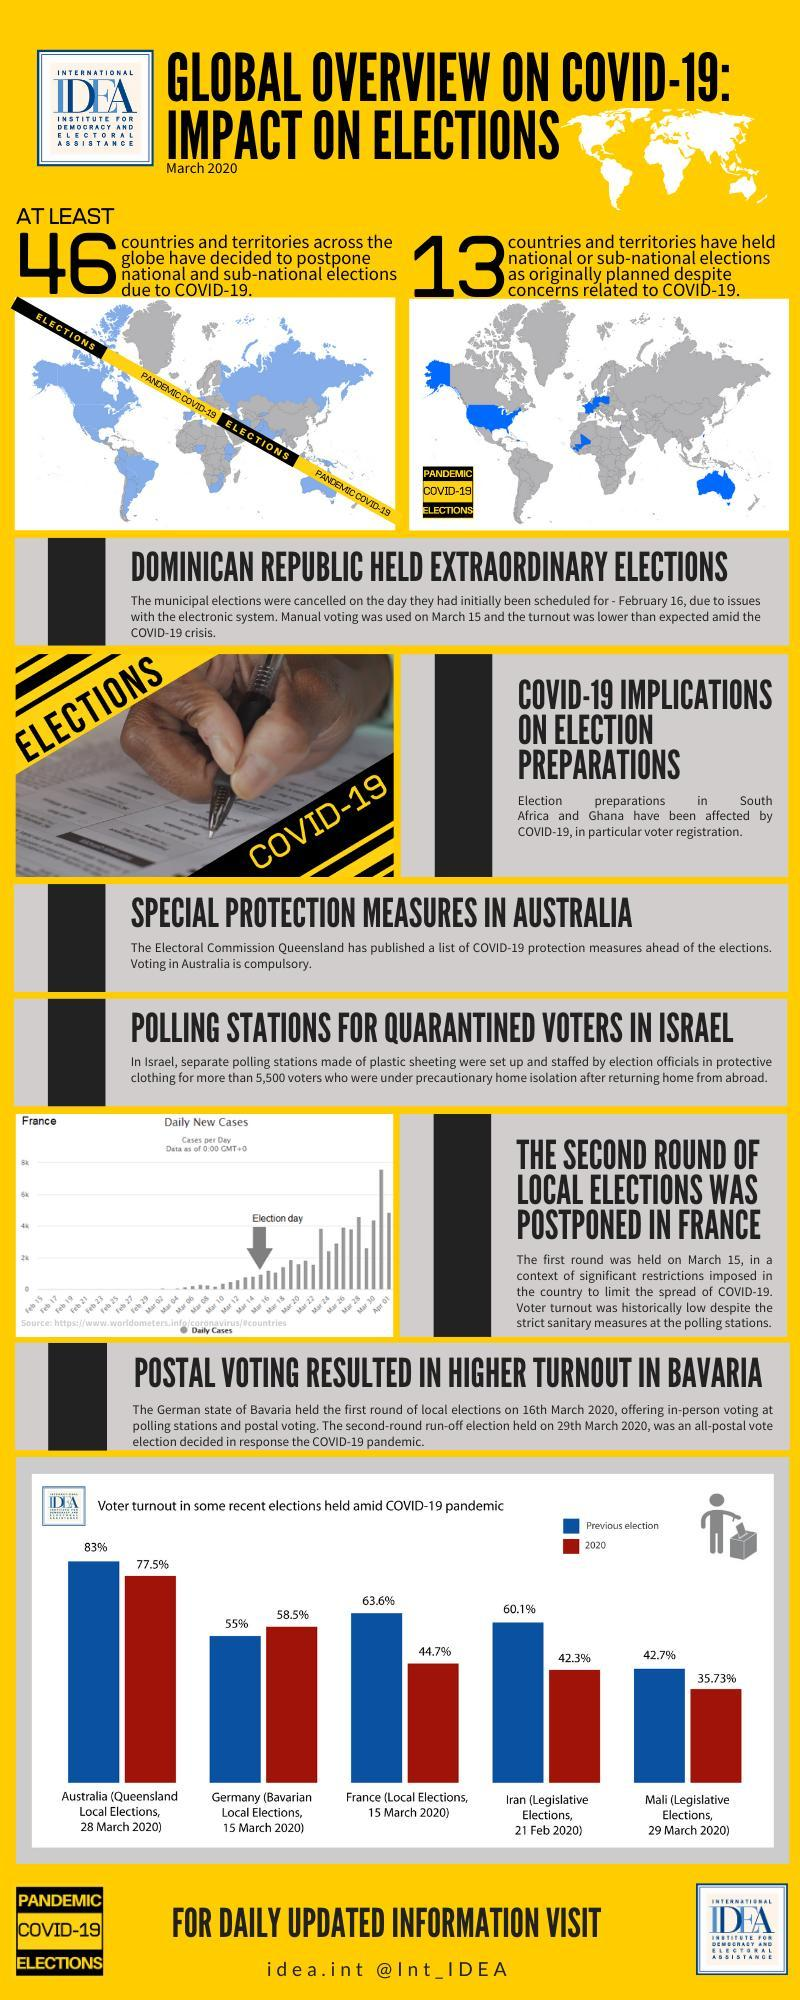What is the voter turnout in the legislative elections of Mali on 29 March 2020?
Answer the question with a short phrase. 35.73% What is the voter turnout in the local elections of France on 15 March 2020? 44.7% What is the voter turnout in the previous legislative elections of Iran? 60.1% 